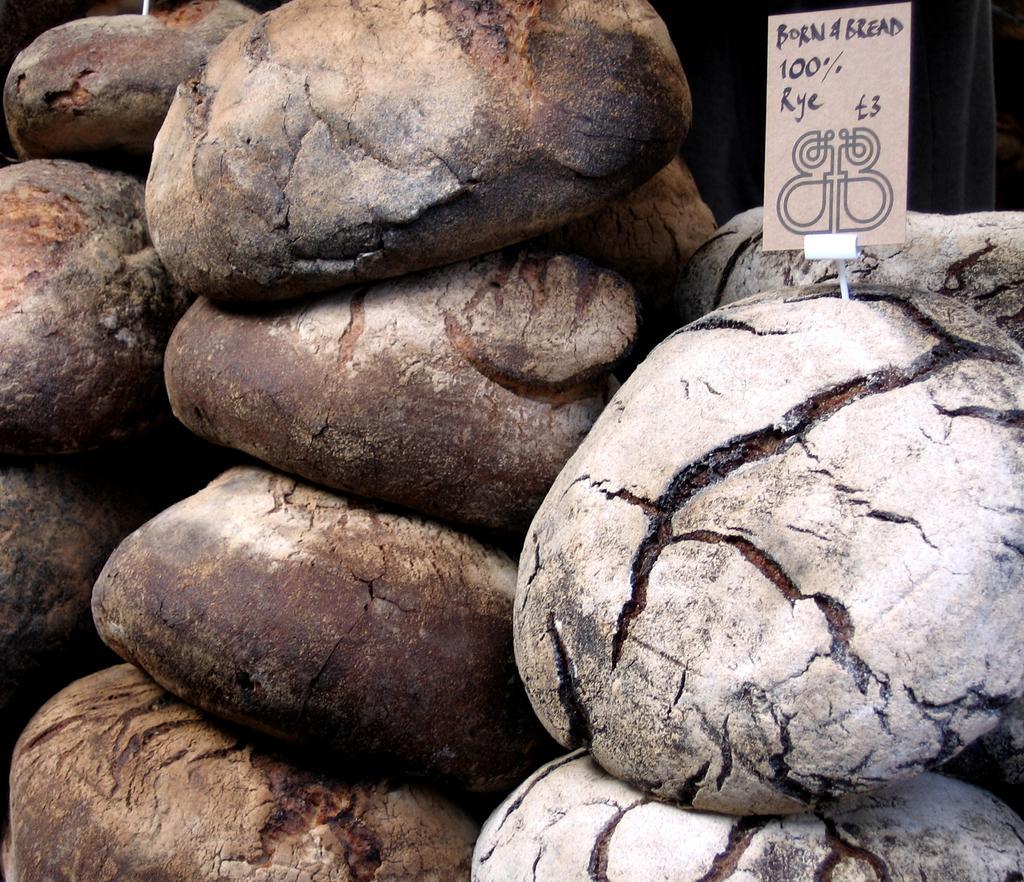In one or two sentences, can you explain what this image depicts? In this image we can see food and card. 